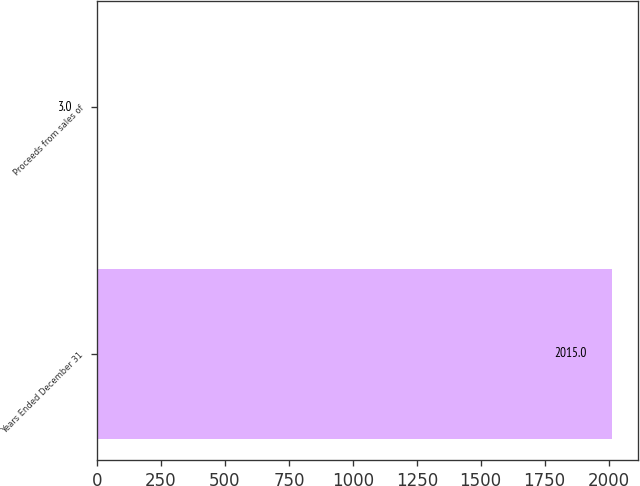Convert chart. <chart><loc_0><loc_0><loc_500><loc_500><bar_chart><fcel>Years Ended December 31<fcel>Proceeds from sales of<nl><fcel>2015<fcel>3<nl></chart> 